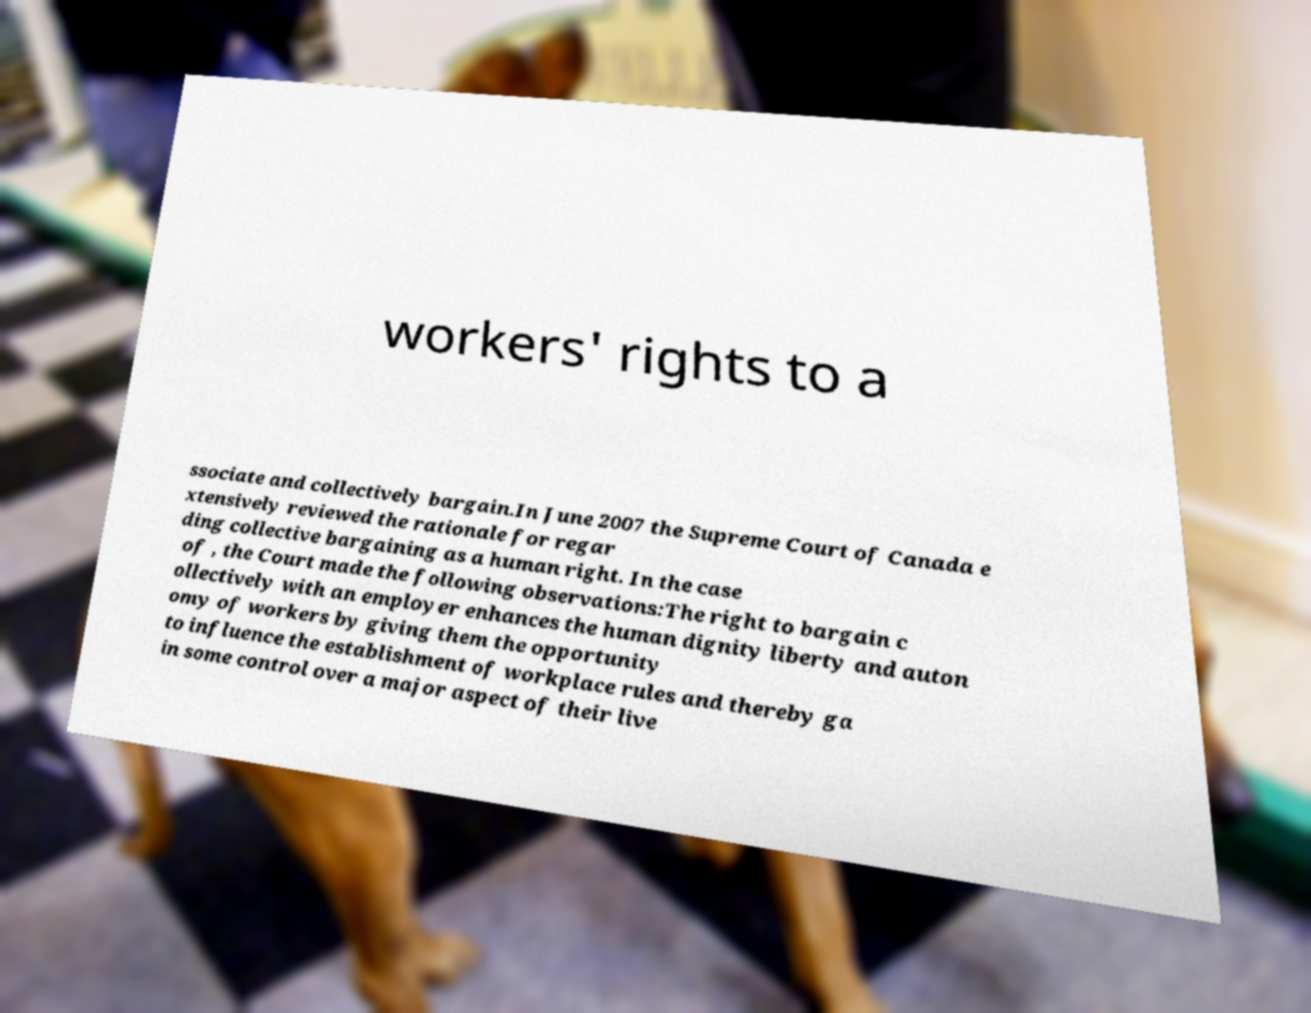Can you read and provide the text displayed in the image?This photo seems to have some interesting text. Can you extract and type it out for me? workers' rights to a ssociate and collectively bargain.In June 2007 the Supreme Court of Canada e xtensively reviewed the rationale for regar ding collective bargaining as a human right. In the case of , the Court made the following observations:The right to bargain c ollectively with an employer enhances the human dignity liberty and auton omy of workers by giving them the opportunity to influence the establishment of workplace rules and thereby ga in some control over a major aspect of their live 